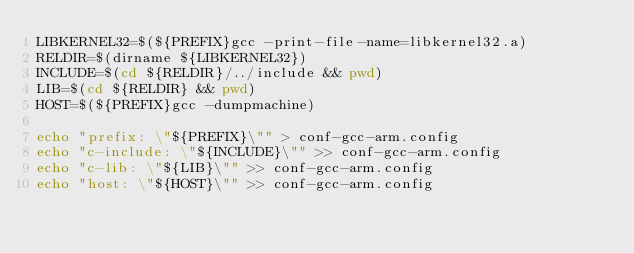Convert code to text. <code><loc_0><loc_0><loc_500><loc_500><_Bash_>LIBKERNEL32=$(${PREFIX}gcc -print-file-name=libkernel32.a)
RELDIR=$(dirname ${LIBKERNEL32})
INCLUDE=$(cd ${RELDIR}/../include && pwd)
LIB=$(cd ${RELDIR} && pwd)
HOST=$(${PREFIX}gcc -dumpmachine)

echo "prefix: \"${PREFIX}\"" > conf-gcc-arm.config
echo "c-include: \"${INCLUDE}\"" >> conf-gcc-arm.config
echo "c-lib: \"${LIB}\"" >> conf-gcc-arm.config
echo "host: \"${HOST}\"" >> conf-gcc-arm.config
</code> 